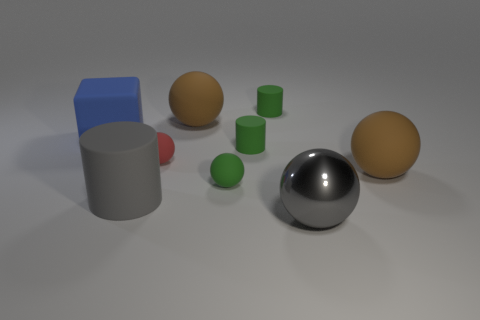Subtract all tiny green rubber spheres. How many spheres are left? 4 Subtract all green balls. How many balls are left? 4 Subtract 3 balls. How many balls are left? 2 Subtract all blue balls. Subtract all gray cubes. How many balls are left? 5 Subtract all cylinders. How many objects are left? 6 Add 4 large blue cylinders. How many large blue cylinders exist? 4 Subtract 0 purple balls. How many objects are left? 9 Subtract all large metal things. Subtract all tiny green objects. How many objects are left? 5 Add 2 green cylinders. How many green cylinders are left? 4 